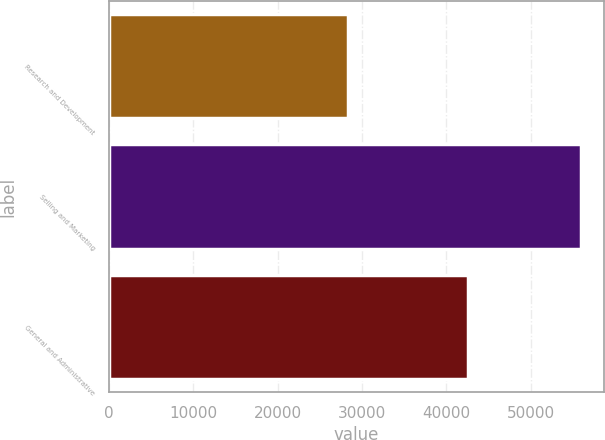Convert chart. <chart><loc_0><loc_0><loc_500><loc_500><bar_chart><fcel>Research and Development<fcel>Selling and Marketing<fcel>General and Administrative<nl><fcel>28294<fcel>55910<fcel>42551<nl></chart> 